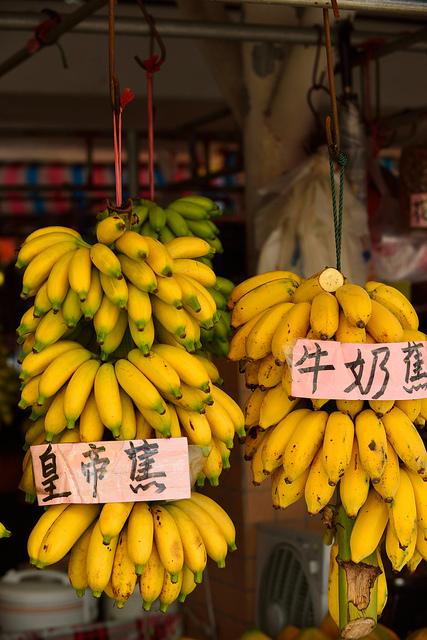How much do these bananas cost?
Concise answer only. 50. What kind of bananas are these?
Give a very brief answer. Yellow. Is someone selling the bananas in the US?
Concise answer only. No. 